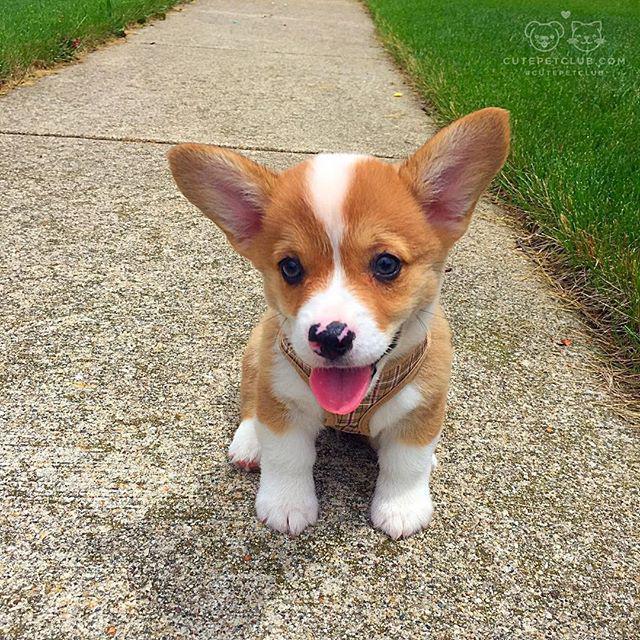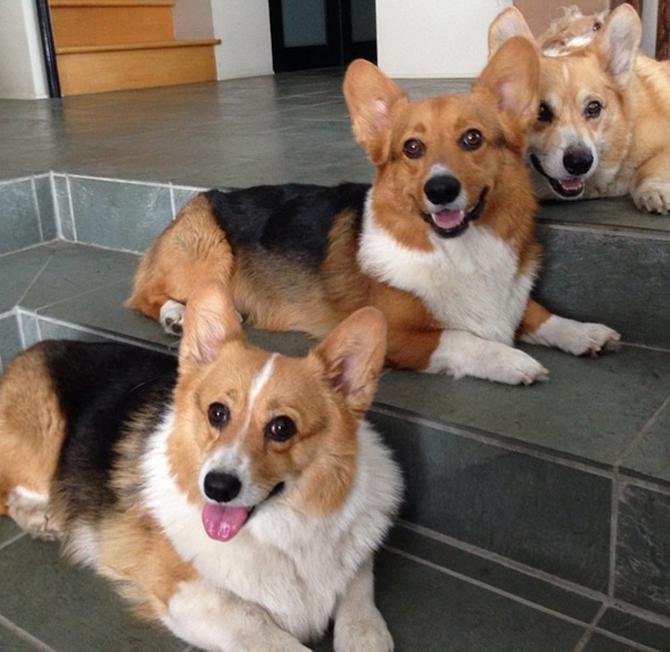The first image is the image on the left, the second image is the image on the right. For the images shown, is this caption "There are three dogs in the right image." true? Answer yes or no. Yes. The first image is the image on the left, the second image is the image on the right. Analyze the images presented: Is the assertion "There are four dogs." valid? Answer yes or no. Yes. 